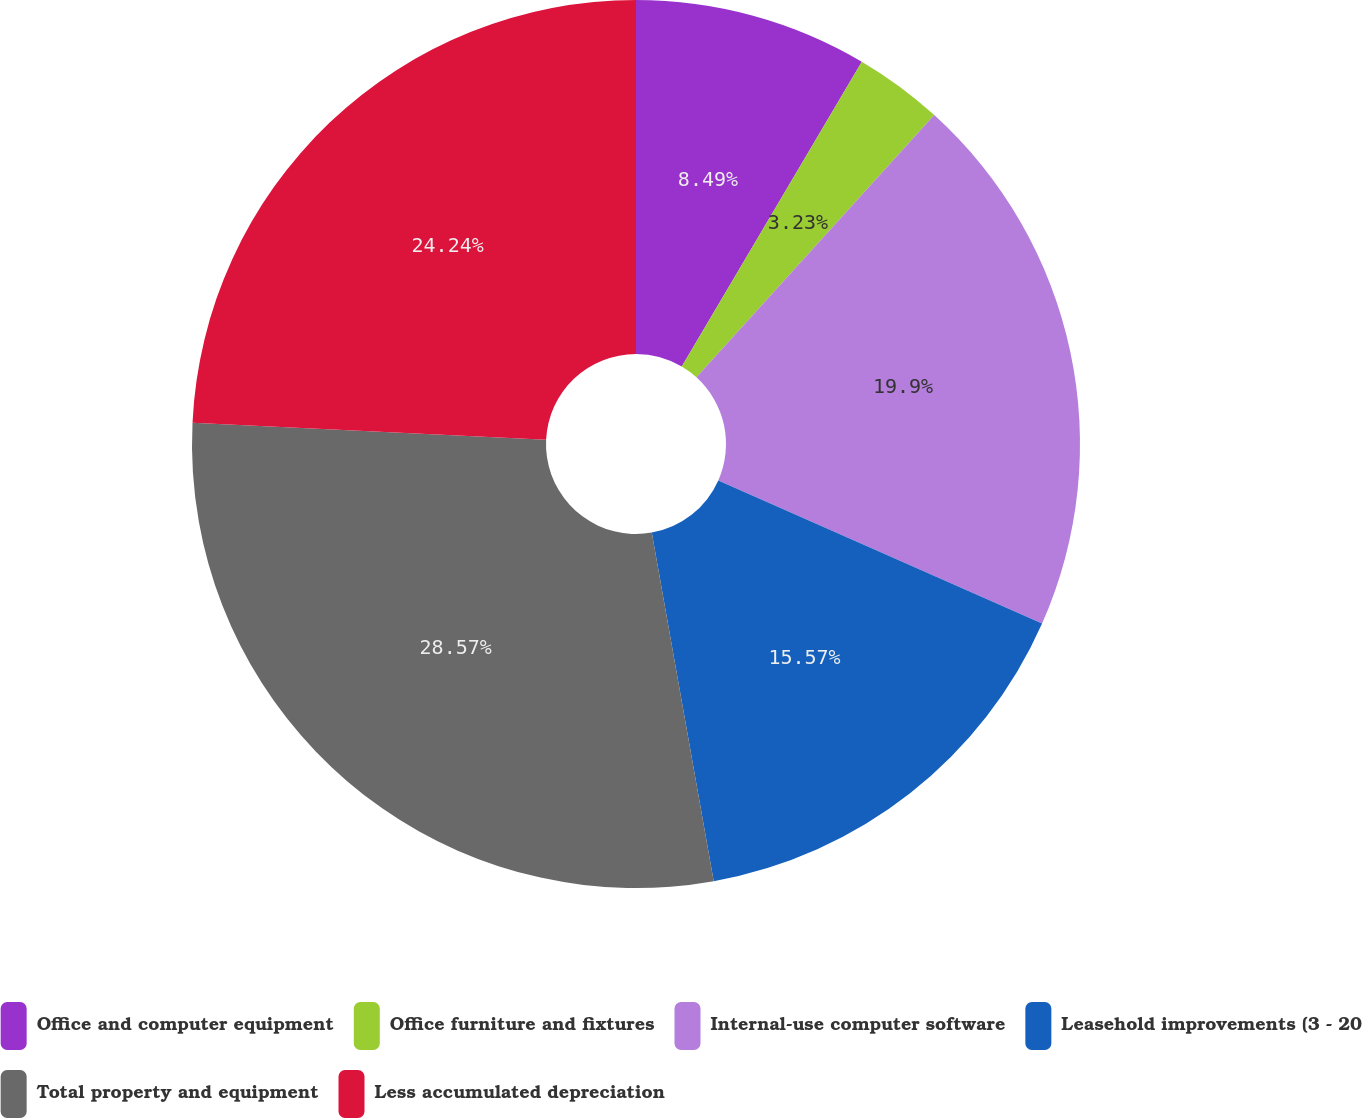Convert chart to OTSL. <chart><loc_0><loc_0><loc_500><loc_500><pie_chart><fcel>Office and computer equipment<fcel>Office furniture and fixtures<fcel>Internal-use computer software<fcel>Leasehold improvements (3 - 20<fcel>Total property and equipment<fcel>Less accumulated depreciation<nl><fcel>8.49%<fcel>3.23%<fcel>19.9%<fcel>15.57%<fcel>28.56%<fcel>24.23%<nl></chart> 